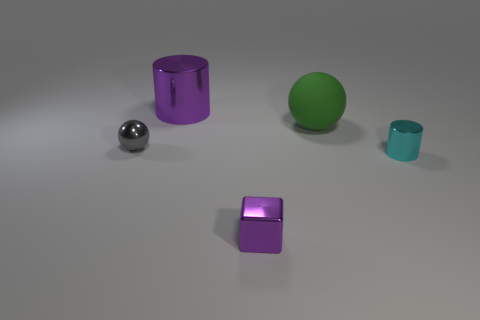Add 1 purple things. How many objects exist? 6 Subtract all purple cylinders. How many cylinders are left? 1 Subtract all cubes. How many objects are left? 4 Subtract 2 cylinders. How many cylinders are left? 0 Subtract all red blocks. Subtract all brown cylinders. How many blocks are left? 1 Subtract all cyan spheres. How many brown cylinders are left? 0 Subtract all large rubber spheres. Subtract all metal objects. How many objects are left? 0 Add 1 tiny purple metallic blocks. How many tiny purple metallic blocks are left? 2 Add 4 purple metallic cubes. How many purple metallic cubes exist? 5 Subtract 1 purple cylinders. How many objects are left? 4 